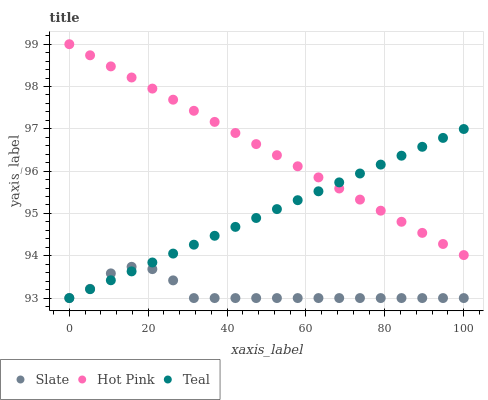Does Slate have the minimum area under the curve?
Answer yes or no. Yes. Does Hot Pink have the maximum area under the curve?
Answer yes or no. Yes. Does Teal have the minimum area under the curve?
Answer yes or no. No. Does Teal have the maximum area under the curve?
Answer yes or no. No. Is Teal the smoothest?
Answer yes or no. Yes. Is Slate the roughest?
Answer yes or no. Yes. Is Hot Pink the smoothest?
Answer yes or no. No. Is Hot Pink the roughest?
Answer yes or no. No. Does Slate have the lowest value?
Answer yes or no. Yes. Does Hot Pink have the lowest value?
Answer yes or no. No. Does Hot Pink have the highest value?
Answer yes or no. Yes. Does Teal have the highest value?
Answer yes or no. No. Is Slate less than Hot Pink?
Answer yes or no. Yes. Is Hot Pink greater than Slate?
Answer yes or no. Yes. Does Teal intersect Slate?
Answer yes or no. Yes. Is Teal less than Slate?
Answer yes or no. No. Is Teal greater than Slate?
Answer yes or no. No. Does Slate intersect Hot Pink?
Answer yes or no. No. 